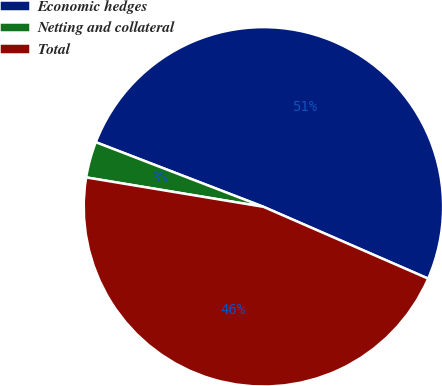Convert chart to OTSL. <chart><loc_0><loc_0><loc_500><loc_500><pie_chart><fcel>Economic hedges<fcel>Netting and collateral<fcel>Total<nl><fcel>50.68%<fcel>3.24%<fcel>46.07%<nl></chart> 